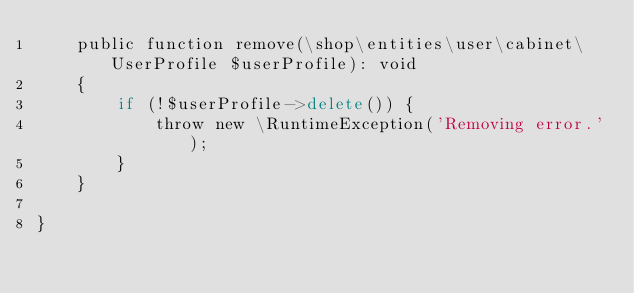Convert code to text. <code><loc_0><loc_0><loc_500><loc_500><_PHP_>    public function remove(\shop\entities\user\cabinet\UserProfile $userProfile): void
    {
        if (!$userProfile->delete()) {
            throw new \RuntimeException('Removing error.');
        }
    }

}</code> 